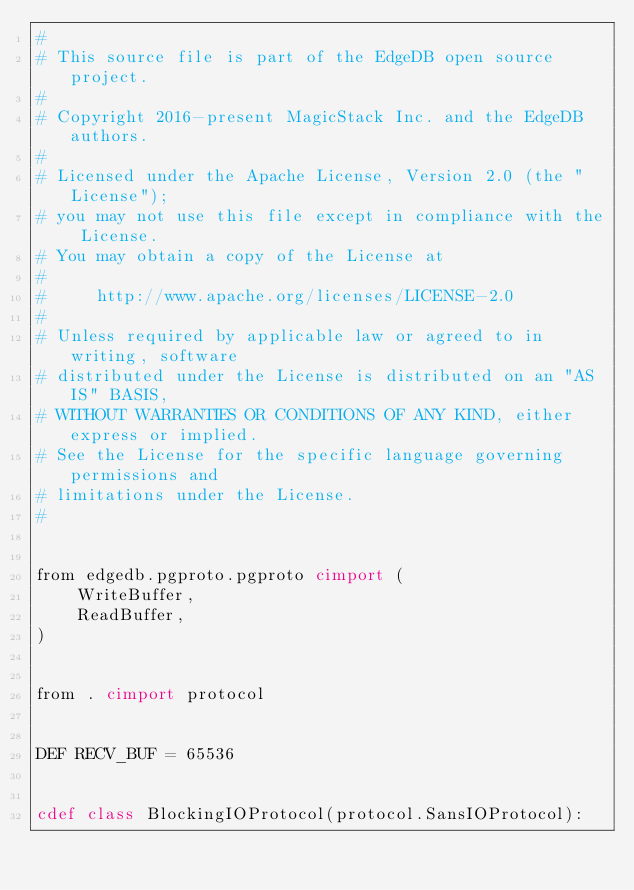Convert code to text. <code><loc_0><loc_0><loc_500><loc_500><_Cython_>#
# This source file is part of the EdgeDB open source project.
#
# Copyright 2016-present MagicStack Inc. and the EdgeDB authors.
#
# Licensed under the Apache License, Version 2.0 (the "License");
# you may not use this file except in compliance with the License.
# You may obtain a copy of the License at
#
#     http://www.apache.org/licenses/LICENSE-2.0
#
# Unless required by applicable law or agreed to in writing, software
# distributed under the License is distributed on an "AS IS" BASIS,
# WITHOUT WARRANTIES OR CONDITIONS OF ANY KIND, either express or implied.
# See the License for the specific language governing permissions and
# limitations under the License.
#


from edgedb.pgproto.pgproto cimport (
    WriteBuffer,
    ReadBuffer,
)


from . cimport protocol


DEF RECV_BUF = 65536


cdef class BlockingIOProtocol(protocol.SansIOProtocol):
</code> 